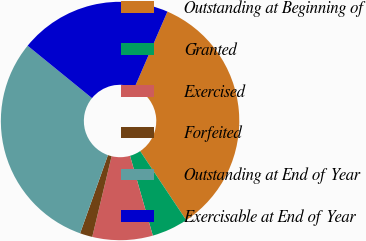Convert chart. <chart><loc_0><loc_0><loc_500><loc_500><pie_chart><fcel>Outstanding at Beginning of<fcel>Granted<fcel>Exercised<fcel>Forfeited<fcel>Outstanding at End of Year<fcel>Exercisable at End of Year<nl><fcel>34.14%<fcel>4.93%<fcel>8.18%<fcel>1.69%<fcel>30.44%<fcel>20.63%<nl></chart> 